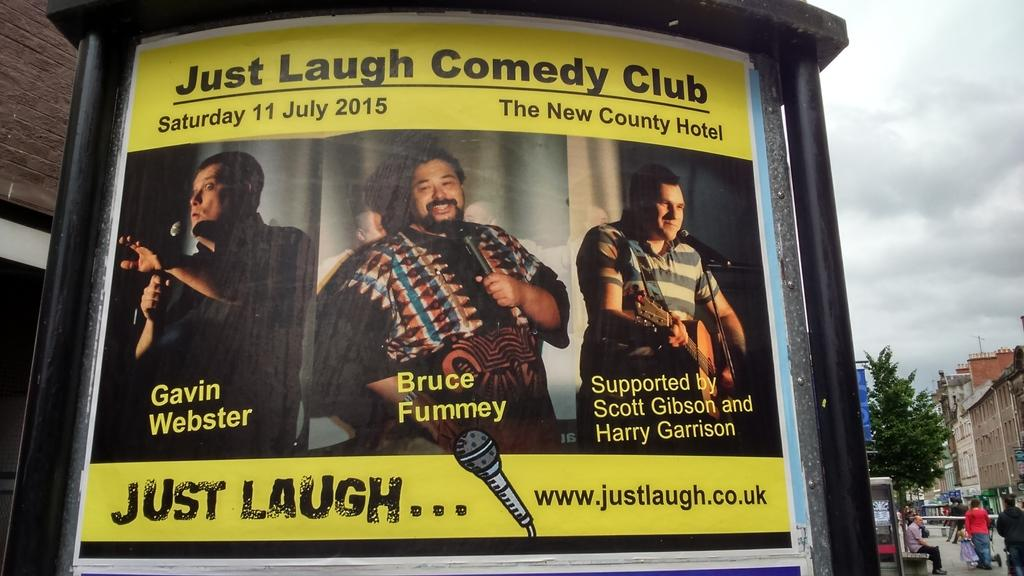What color is the wall in the image? The wall in the image is black. What is on the wall in the image? There is a yellow poster on the wall. What is written on the yellow poster? The word "laugh" is written on the poster. Can you hear the rhythm of the owl's hooting in the image? There is no owl or any sound present in the image, so it is not possible to hear any rhythm. 